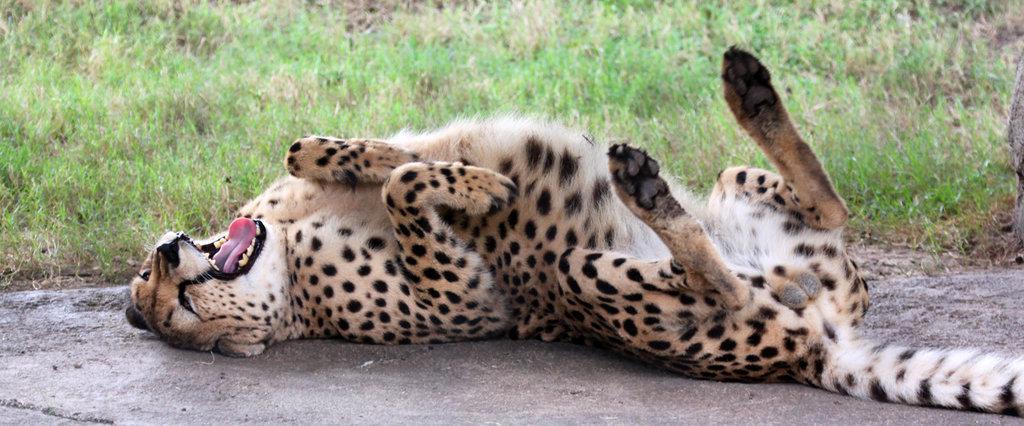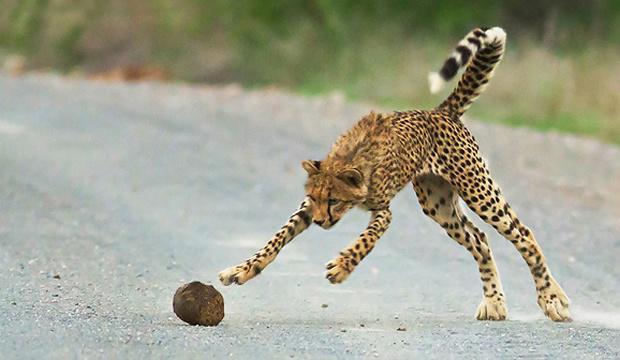The first image is the image on the left, the second image is the image on the right. For the images shown, is this caption "There are at least four cheetahs in the right image." true? Answer yes or no. No. The first image is the image on the left, the second image is the image on the right. Given the left and right images, does the statement "An image includes a wild spotted cat in a pouncing pose, with its tail up and both its front paws off the ground." hold true? Answer yes or no. Yes. 